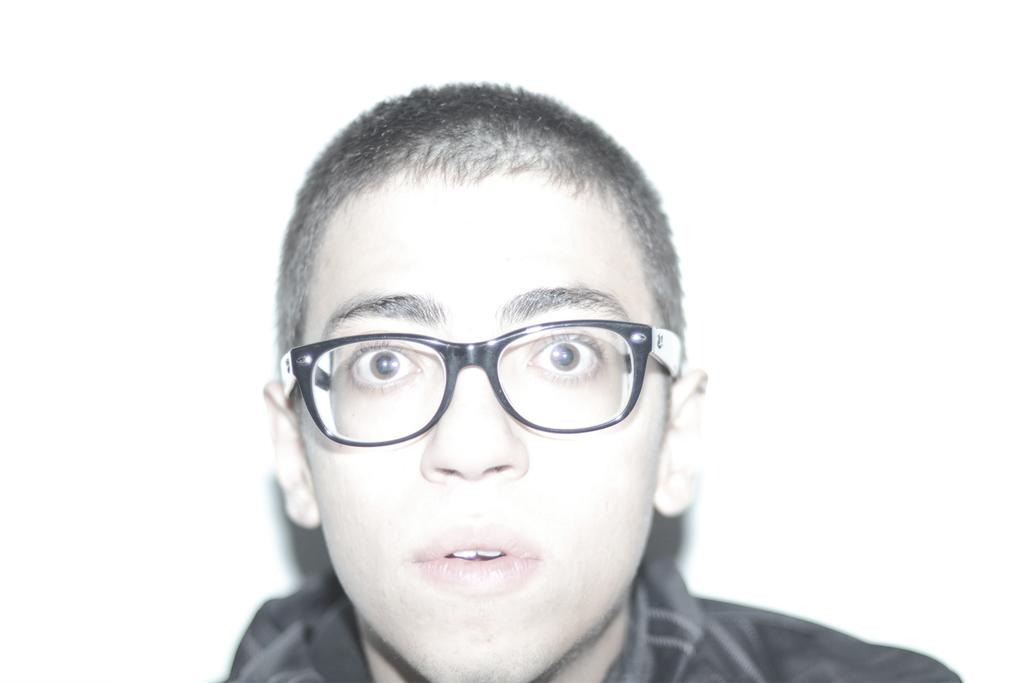Who is the main subject in the image? There is a boy in the image. What is the boy wearing on his face? The boy is wearing specks. What color is the shirt the boy is wearing? The boy is wearing a black shirt. What can be seen in the background of the image? There is a white wall in the background of the image. What type of oven is the boy using in the image? There is no oven present in the image; it features a boy wearing specks and a black shirt in front of a white wall. 